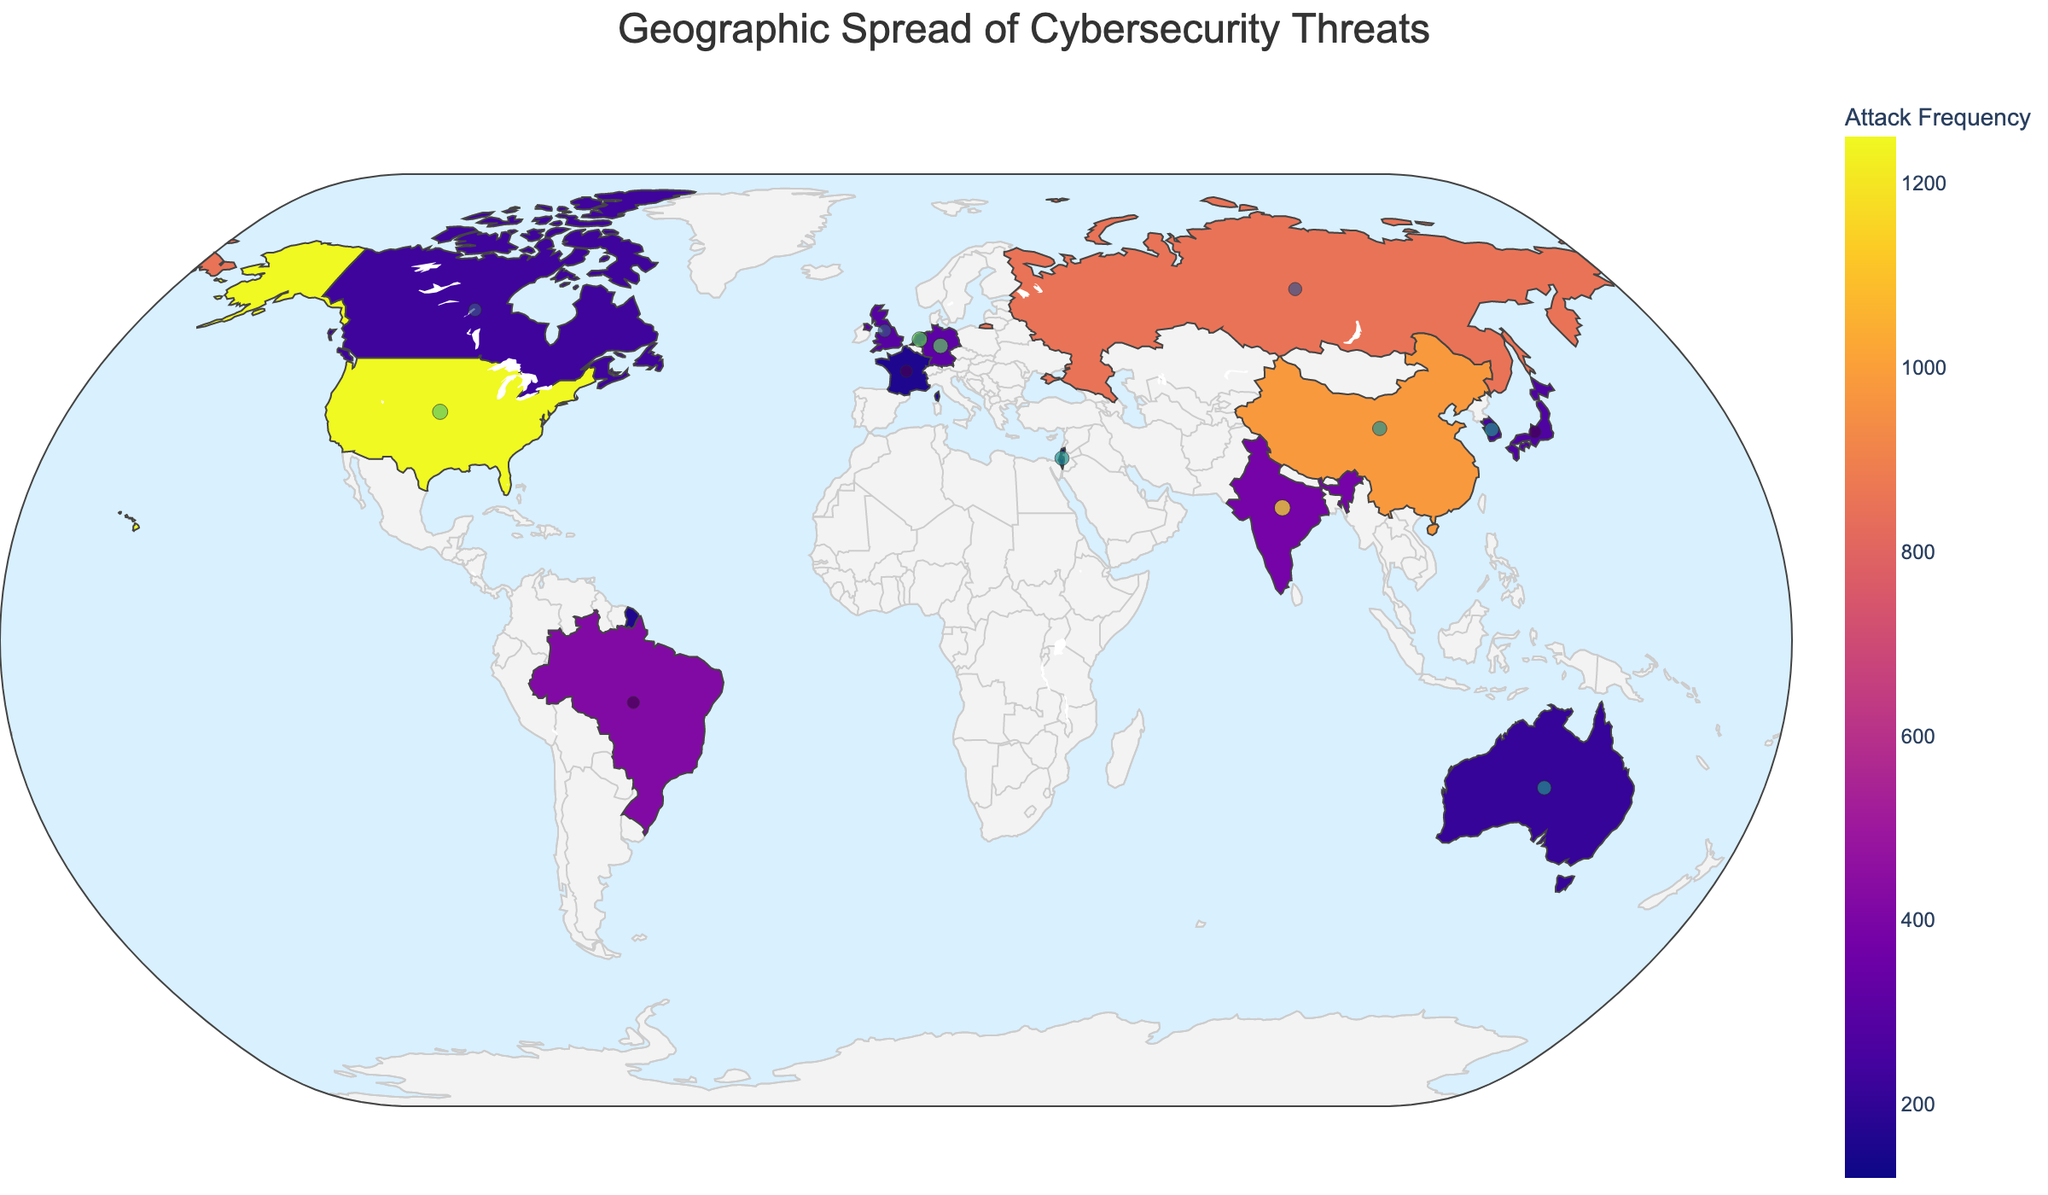What's the title of the figure? The title of the figure is usually prominently displayed at the top of the plot, often in a larger and bold font relative to the other text elements. In this plot, the title is "Geographic Spread of Cybersecurity Threats".
Answer: Geographic Spread of Cybersecurity Threats Which country experiences the most frequent cybersecurity attacks? By looking at the figure, the country with the highest color intensity, corresponding to the highest frequency of attacks, is the United States. This can also be confirmed by observing the color bar legend that maps frequency values to colors.
Answer: United States What type of attack is most frequent in Brazil, and what is its severity? By either hovering over Brazil or looking at the bubble chart overlaying the map, we can observe the details provided. For Brazil, the most frequent attack is "SQL Injection" with a severity of 5.
Answer: SQL Injection, 5 What is the combined attack frequency of the United States and China? The frequency for the United States is 1250, and for China, it is 980. Adding these values together gives us the total attack frequency: 1250 + 980 = 2230.
Answer: 2230 Which two countries have the highest severity levels for cybersecurity threats? We look for the largest bubbles (sizes represent the severity) and see that India and Singapore have the highest severity levels, both marked with a severity score of 9.
Answer: India and Singapore Compare the cybersecurity threat severity between Germany and Canada. Which country has a higher severity, and what are their values? By comparing the bubble sizes directly or by the hover data, Germany has a severity of 8 while Canada has a severity of 6. Therefore, Germany has a higher severity.
Answer: Germany, 8 > 6 What is the average severity of the cybersecurity threats experienced by the United Kingdom, Japan, and South Korea? The severities for these countries are as follows: United Kingdom (6), Japan (5), and South Korea (7). Calculating the average: (6 + 5 + 7) / 3 = 6.
Answer: 6 Are there more countries with a frequency of attacks above 300 or below 300? Count the countries with attack frequency values above and below 300. Above 300: United States, China, Russia, Brazil, India, Germany. Below 300: United Kingdom, Japan, South Korea, Canada, Australia, Netherlands, France, Singapore, Israel. 6 countries are above 300, and 9 are below 300.
Answer: Below 300 Which region (continent) is highlighted the most for attack frequencies? By observing the color intensity across different continents, we can see that North America (United States, Canada) and Asia (China, India, Japan, South Korea) have significant frequencies. North America has the highest frequency due to the United States.
Answer: North America 